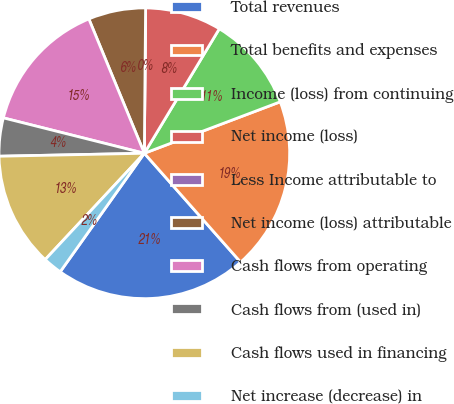Convert chart to OTSL. <chart><loc_0><loc_0><loc_500><loc_500><pie_chart><fcel>Total revenues<fcel>Total benefits and expenses<fcel>Income (loss) from continuing<fcel>Net income (loss)<fcel>Less Income attributable to<fcel>Net income (loss) attributable<fcel>Cash flows from operating<fcel>Cash flows from (used in)<fcel>Cash flows used in financing<fcel>Net increase (decrease) in<nl><fcel>21.35%<fcel>19.23%<fcel>10.61%<fcel>8.49%<fcel>0.0%<fcel>6.37%<fcel>14.85%<fcel>4.24%<fcel>12.73%<fcel>2.12%<nl></chart> 